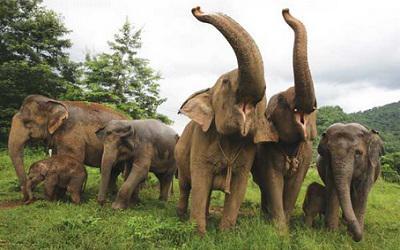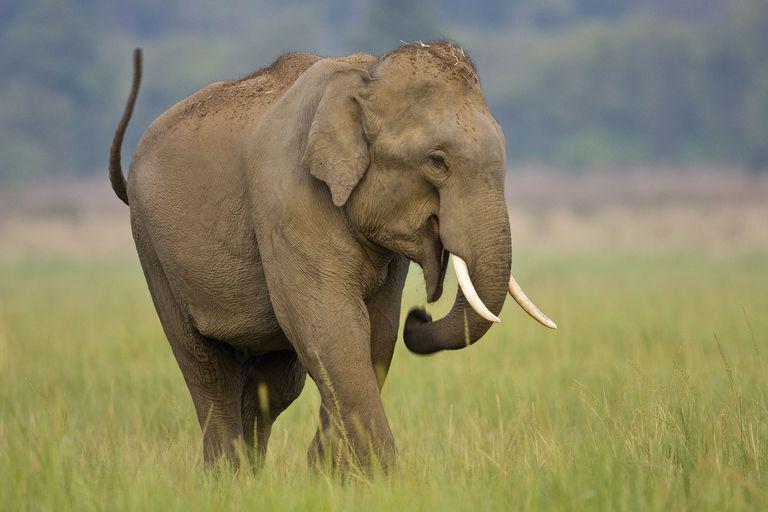The first image is the image on the left, the second image is the image on the right. Analyze the images presented: Is the assertion "There are two elephants in total." valid? Answer yes or no. No. 